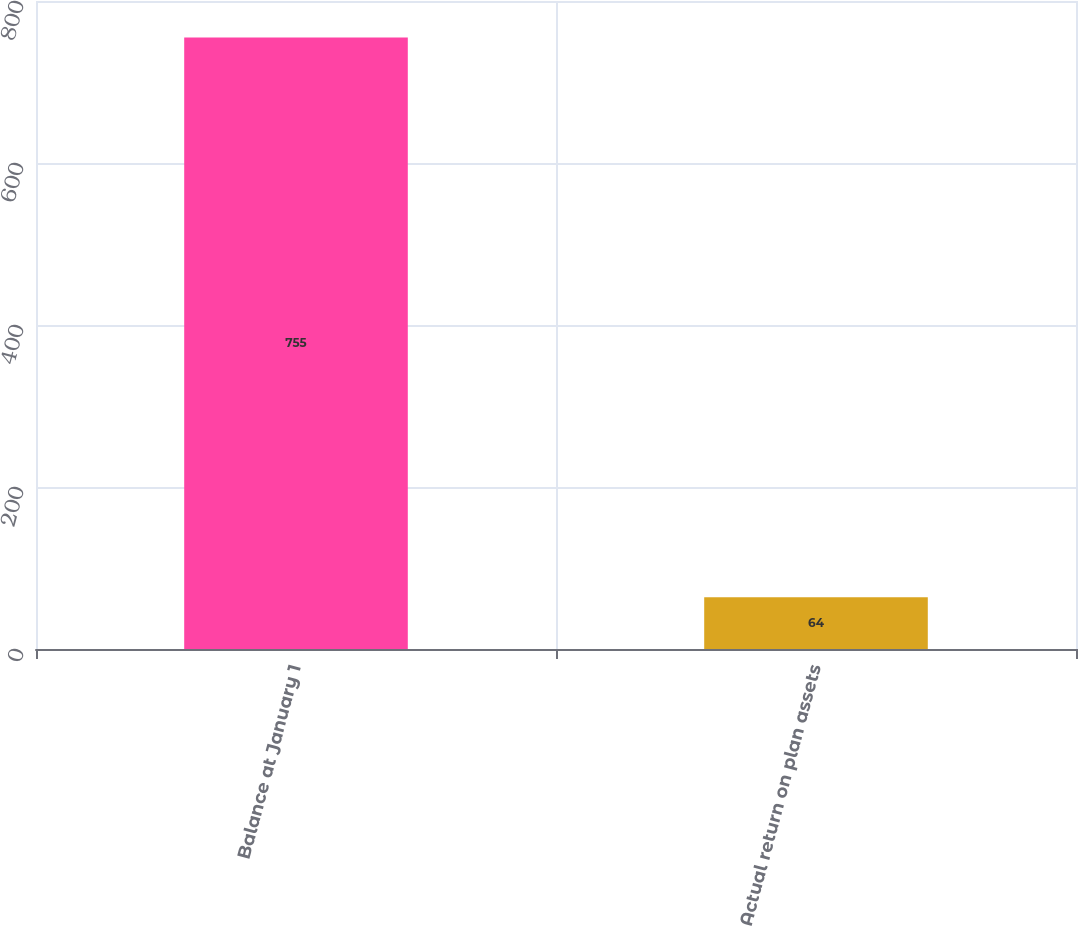<chart> <loc_0><loc_0><loc_500><loc_500><bar_chart><fcel>Balance at January 1<fcel>Actual return on plan assets<nl><fcel>755<fcel>64<nl></chart> 